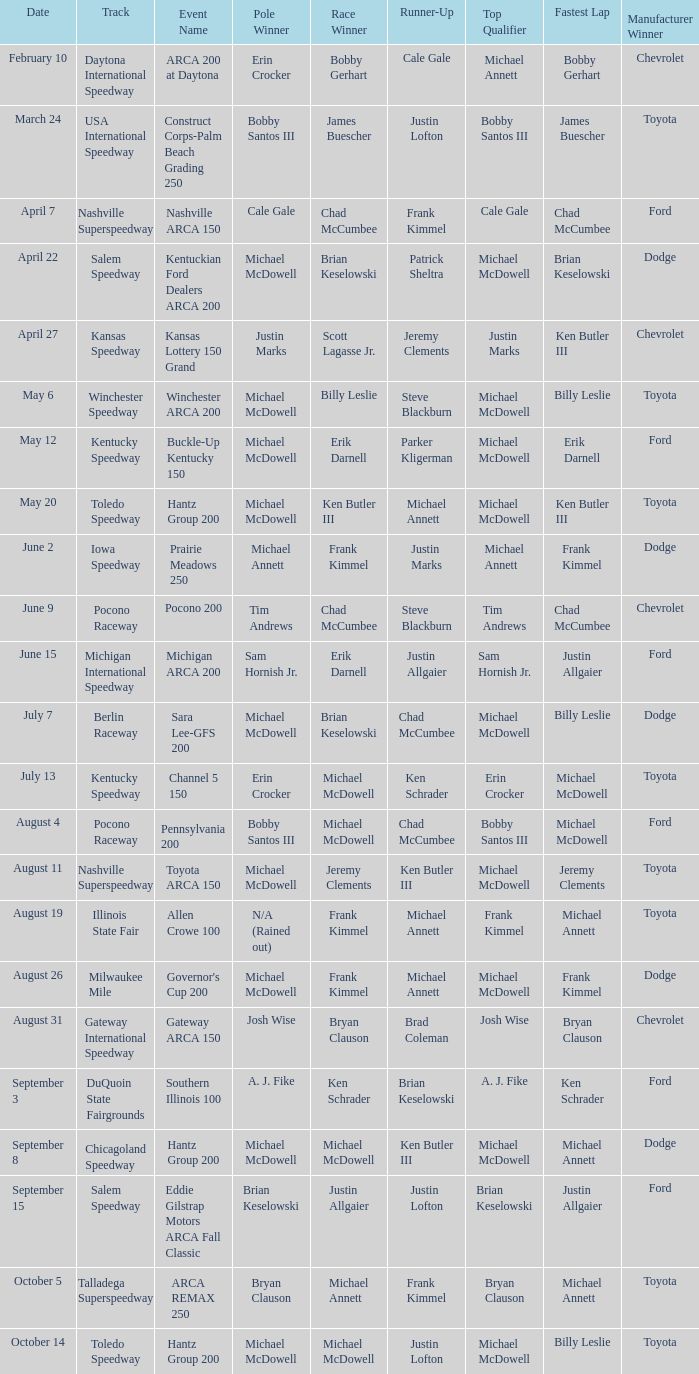Tell me the track for june 9 Pocono Raceway. 